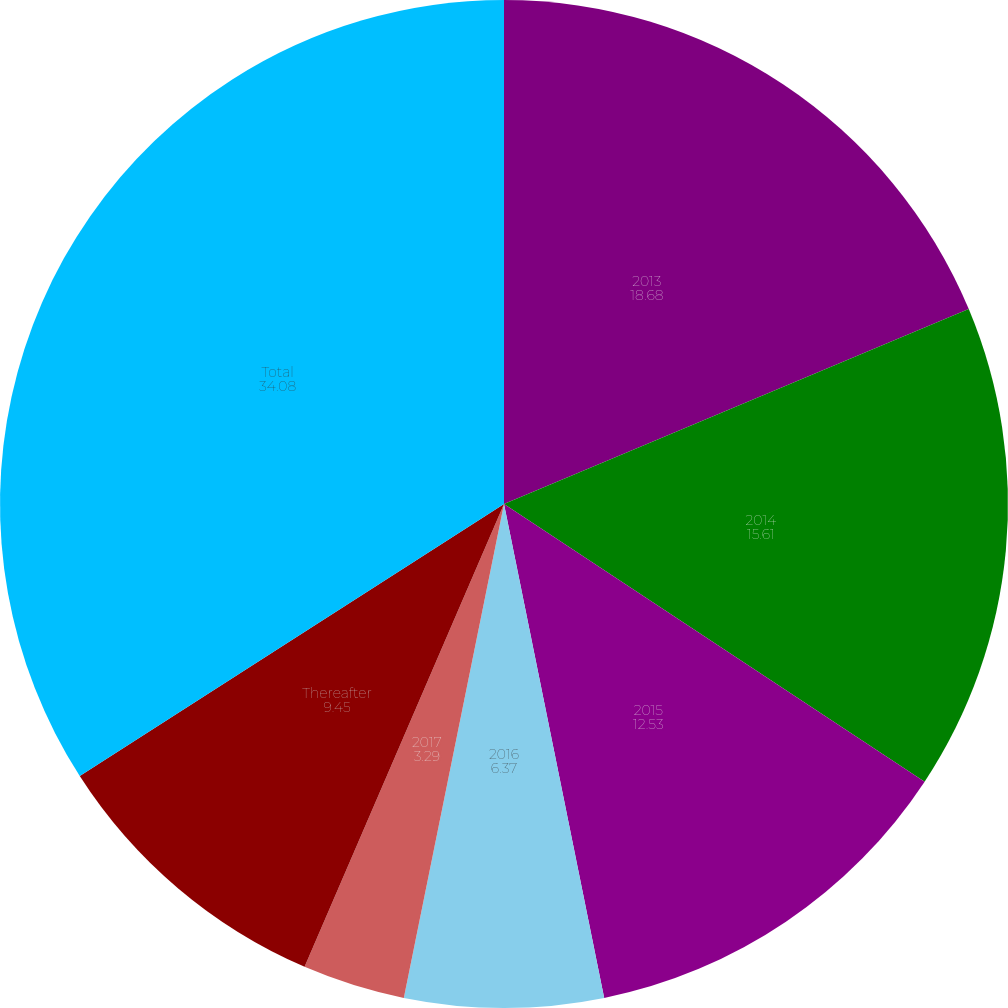Convert chart. <chart><loc_0><loc_0><loc_500><loc_500><pie_chart><fcel>2013<fcel>2014<fcel>2015<fcel>2016<fcel>2017<fcel>Thereafter<fcel>Total<nl><fcel>18.68%<fcel>15.61%<fcel>12.53%<fcel>6.37%<fcel>3.29%<fcel>9.45%<fcel>34.08%<nl></chart> 